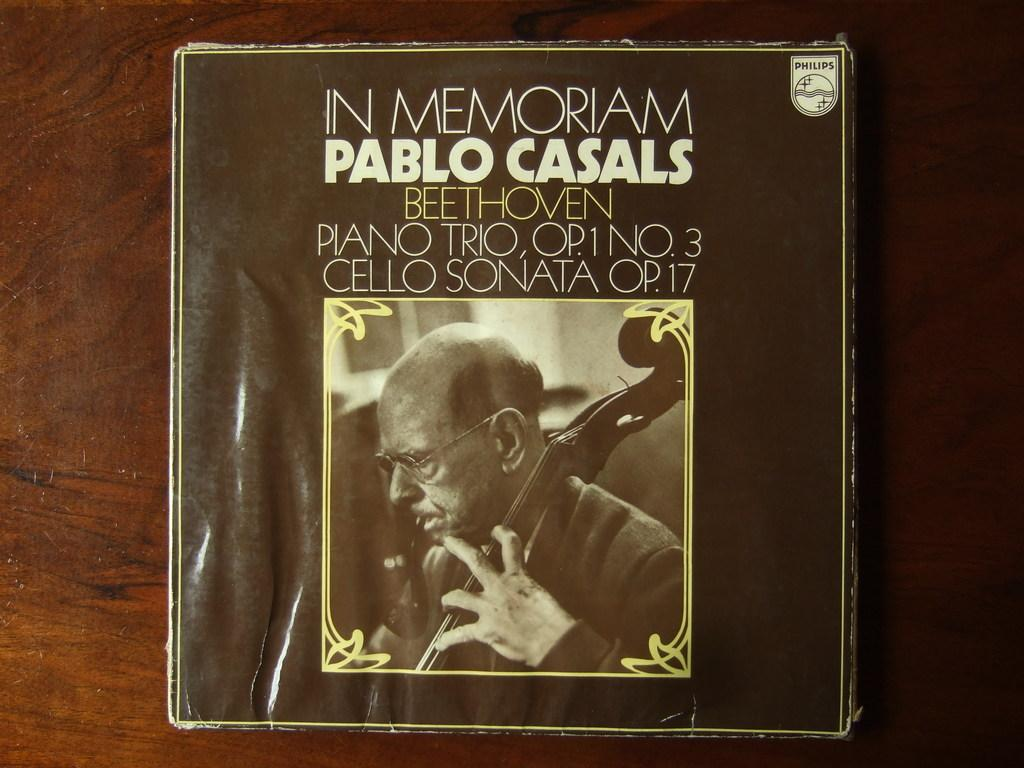<image>
Offer a succinct explanation of the picture presented. An album features Pablo Casals playing the music of Beethoven. 